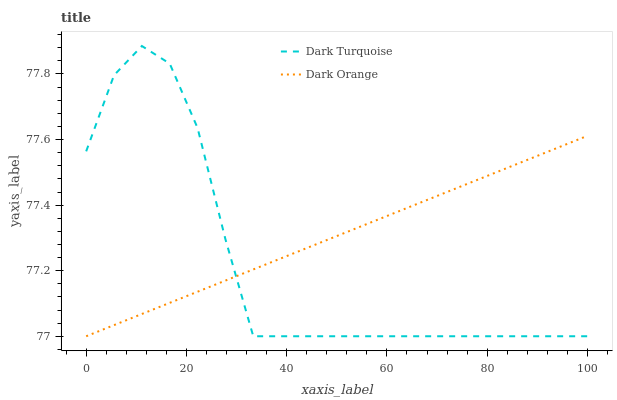Does Dark Turquoise have the minimum area under the curve?
Answer yes or no. Yes. Does Dark Orange have the maximum area under the curve?
Answer yes or no. Yes. Does Dark Orange have the minimum area under the curve?
Answer yes or no. No. Is Dark Orange the smoothest?
Answer yes or no. Yes. Is Dark Turquoise the roughest?
Answer yes or no. Yes. Is Dark Orange the roughest?
Answer yes or no. No. Does Dark Turquoise have the lowest value?
Answer yes or no. Yes. Does Dark Turquoise have the highest value?
Answer yes or no. Yes. Does Dark Orange have the highest value?
Answer yes or no. No. Does Dark Turquoise intersect Dark Orange?
Answer yes or no. Yes. Is Dark Turquoise less than Dark Orange?
Answer yes or no. No. Is Dark Turquoise greater than Dark Orange?
Answer yes or no. No. 